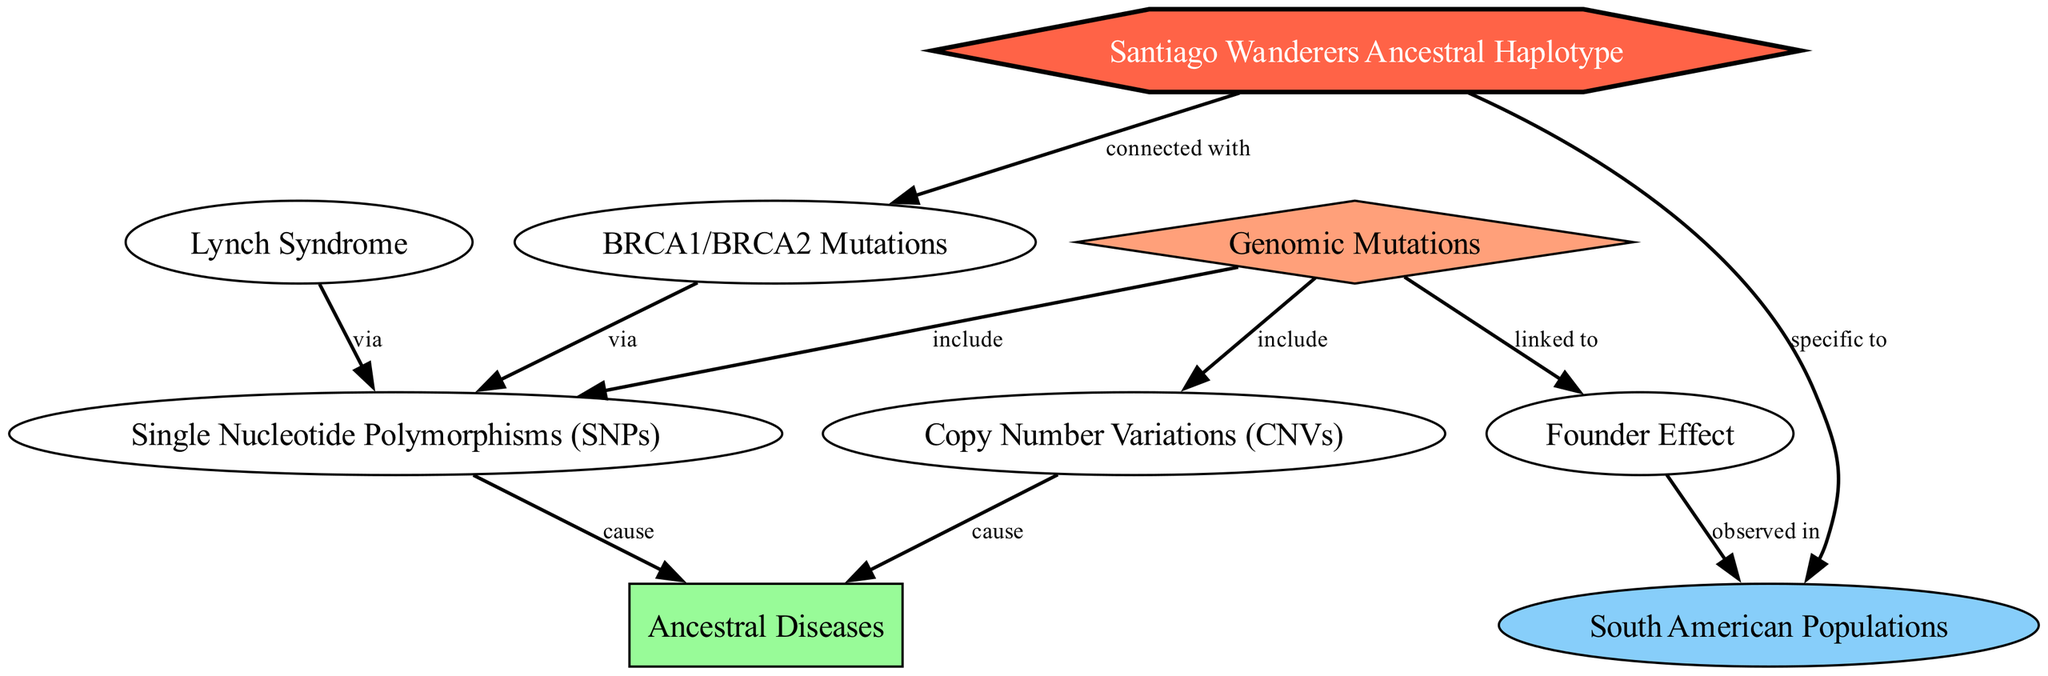What is the total number of nodes in the diagram? The diagram features nodes representing significant concepts like genomic mutations, ancestral diseases, and specific mutations linked to South American populations. By counting each distinct node listed, we find there are a total of 9 nodes.
Answer: 9 What type of mutations are included under genomic mutations in the diagram? The edges indicate that the genomic mutations include Single Nucleotide Polymorphisms (SNPs) and Copy Number Variations (CNVs). These are explicitly defined by the edges leading from "Genomic Mutations" to each of these nodes.
Answer: Single Nucleotide Polymorphisms (SNPs) and Copy Number Variations (CNVs) Which ancestral disease is linked to Single Nucleotide Polymorphisms? The edge from the SNPs node towards the Ancestral Diseases node shows a causal relationship, indicating that SNPs are a contributing factor to ancestral diseases. We can identify that Lynch Syndrome is one ancestral disease associated with genetic mutations in this context.
Answer: Lynch Syndrome How are the Santiago Wanderers Ancestral Haplotype and South American Populations connected? The diagram illustrates a directed edge from the Santiago Wanderers Ancestral Haplotype to the South American Populations, which is indicated by the label "specific to". This shows that this haplotype is particularly relevant or unique to these populations.
Answer: specific to What is the relationship between BRCA1/BRCA2 mutations and Single Nucleotide Polymorphisms? The diagram shows that BRCA1/BRCA2 mutations are linked to Single Nucleotide Polymorphisms through a directed edge labeled "via". This establishes the connection between these mutations and the mutations classified under genomic mutations, specifically SNPs.
Answer: via 